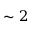Convert formula to latex. <formula><loc_0><loc_0><loc_500><loc_500>\sim 2</formula> 